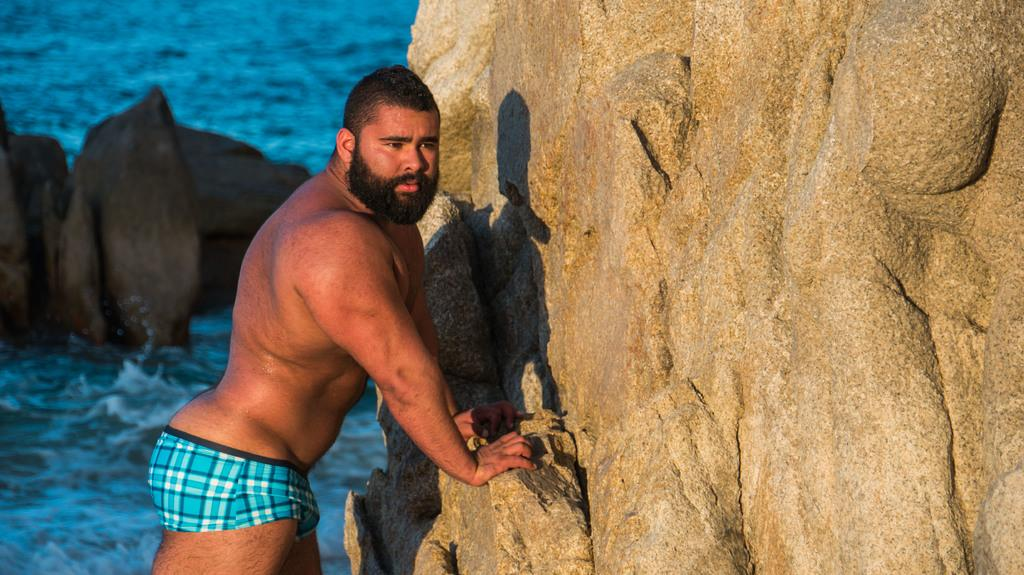What is the man in the image doing? The man is standing in the image and holding a rock. What else can be seen in the water in the image? There are rocks in the water in the image. What type of government is depicted in the image? There is no government depicted in the image; it features a man standing and holding a rock, as well as rocks in the water. How many fingers is the man using to hold the rock in the image? The image does not show the man's fingers, so it cannot be determined how many fingers he is using to hold the rock. 